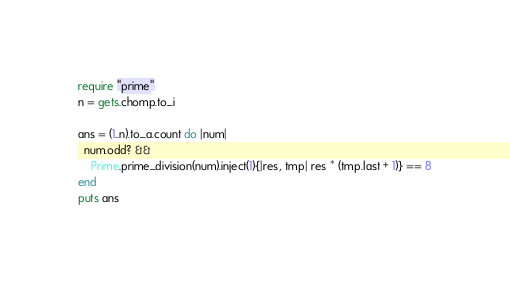<code> <loc_0><loc_0><loc_500><loc_500><_Ruby_>require "prime"
n = gets.chomp.to_i
  
ans = (1..n).to_a.count do |num|
  num.odd? &&
    Prime.prime_division(num).inject(1){|res, tmp| res * (tmp.last + 1)} == 8
end
puts ans
</code> 